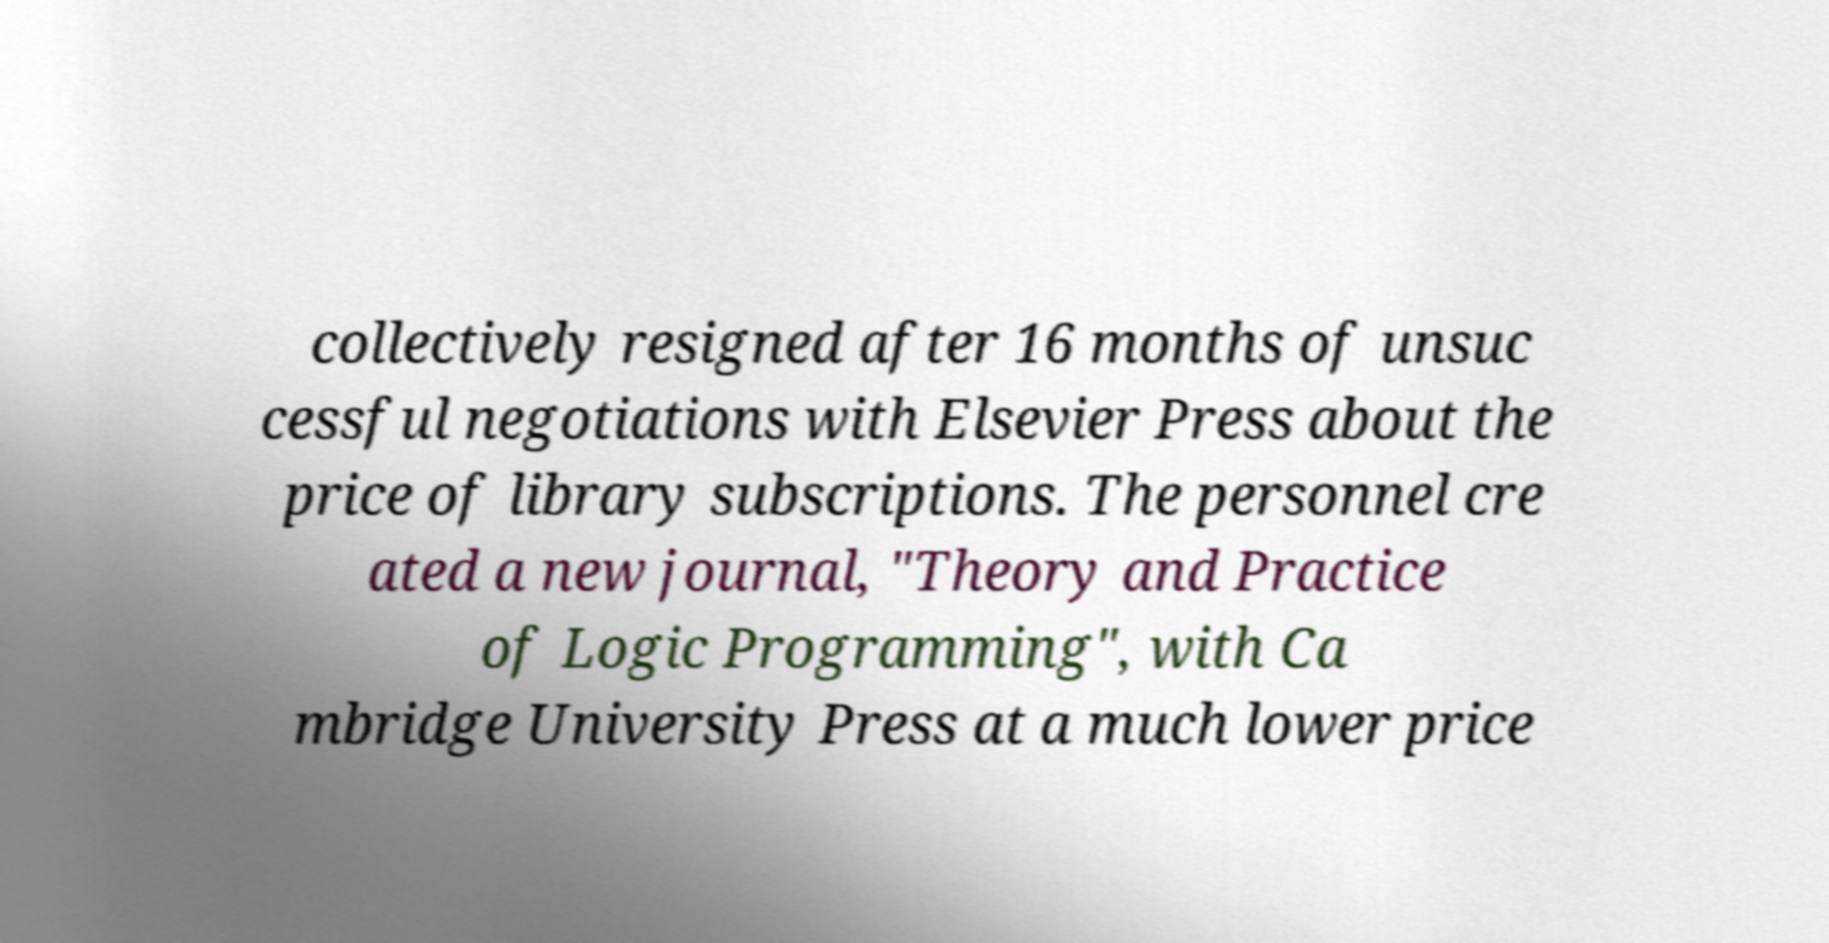Can you accurately transcribe the text from the provided image for me? collectively resigned after 16 months of unsuc cessful negotiations with Elsevier Press about the price of library subscriptions. The personnel cre ated a new journal, "Theory and Practice of Logic Programming", with Ca mbridge University Press at a much lower price 